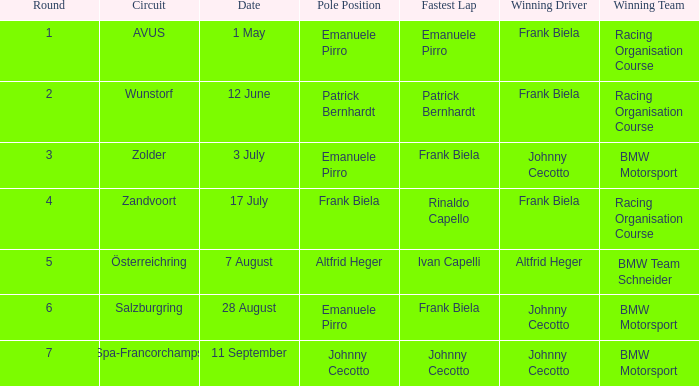What stage was circuit avus? 1.0. 